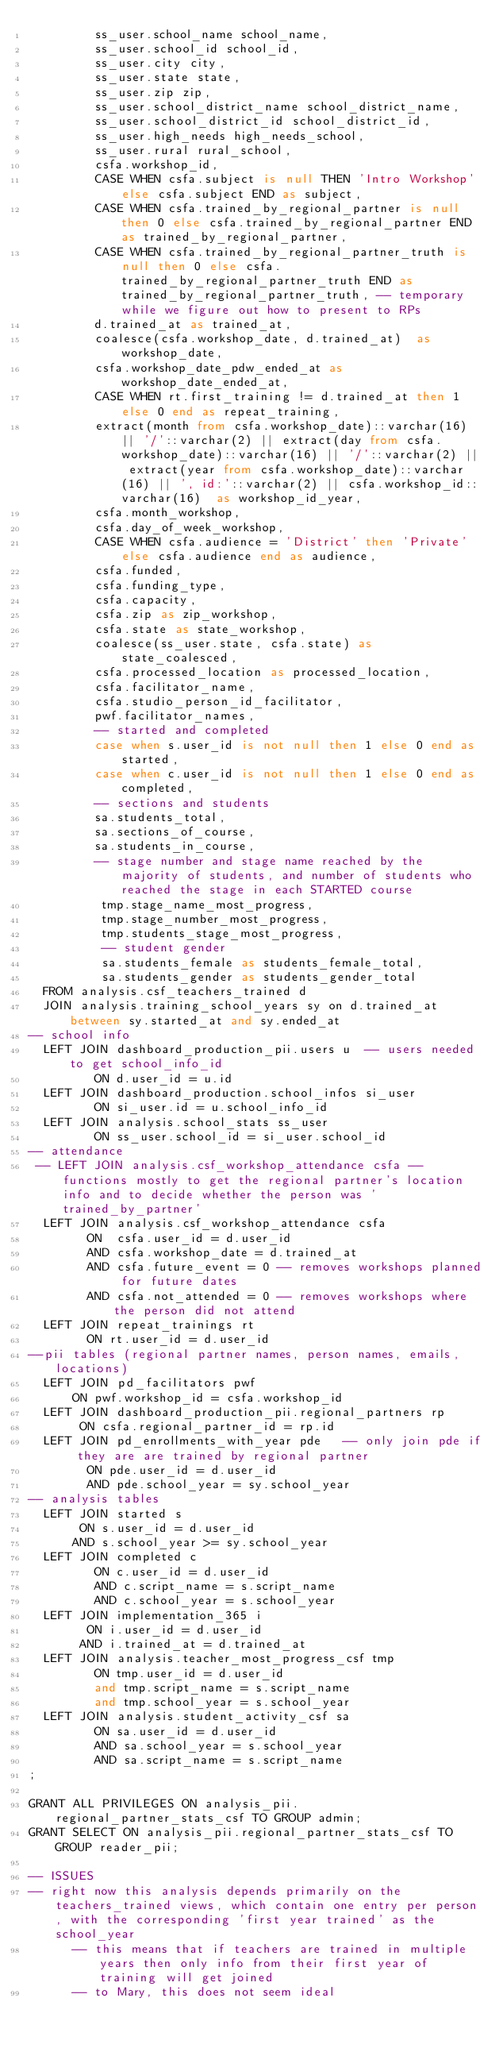Convert code to text. <code><loc_0><loc_0><loc_500><loc_500><_SQL_>         ss_user.school_name school_name,
         ss_user.school_id school_id,
         ss_user.city city,
         ss_user.state state,
         ss_user.zip zip,
         ss_user.school_district_name school_district_name,
         ss_user.school_district_id school_district_id,
         ss_user.high_needs high_needs_school,
         ss_user.rural rural_school, 
         csfa.workshop_id,
         CASE WHEN csfa.subject is null THEN 'Intro Workshop' else csfa.subject END as subject,
         CASE WHEN csfa.trained_by_regional_partner is null then 0 else csfa.trained_by_regional_partner END as trained_by_regional_partner,
         CASE WHEN csfa.trained_by_regional_partner_truth is null then 0 else csfa.trained_by_regional_partner_truth END as trained_by_regional_partner_truth, -- temporary while we figure out how to present to RPs
         d.trained_at as trained_at,
         coalesce(csfa.workshop_date, d.trained_at)  as workshop_date, 
         csfa.workshop_date_pdw_ended_at as workshop_date_ended_at,
         CASE WHEN rt.first_training != d.trained_at then 1 else 0 end as repeat_training,
         extract(month from csfa.workshop_date)::varchar(16) || '/'::varchar(2) || extract(day from csfa.workshop_date)::varchar(16) || '/'::varchar(2) || extract(year from csfa.workshop_date)::varchar(16) || ', id:'::varchar(2) || csfa.workshop_id::varchar(16)  as workshop_id_year,
         csfa.month_workshop,
         csfa.day_of_week_workshop,
         CASE WHEN csfa.audience = 'District' then 'Private' else csfa.audience end as audience,
         csfa.funded,
         csfa.funding_type,
         csfa.capacity,
         csfa.zip as zip_workshop,
         csfa.state as state_workshop,
         coalesce(ss_user.state, csfa.state) as state_coalesced,
         csfa.processed_location as processed_location,
         csfa.facilitator_name, 
         csfa.studio_person_id_facilitator,     
         pwf.facilitator_names,
         -- started and completed
         case when s.user_id is not null then 1 else 0 end as started,
         case when c.user_id is not null then 1 else 0 end as completed,
         -- sections and students   
         sa.students_total,         
         sa.sections_of_course,
         sa.students_in_course,
         -- stage number and stage name reached by the majority of students, and number of students who reached the stage in each STARTED course
          tmp.stage_name_most_progress,
          tmp.stage_number_most_progress, 
          tmp.students_stage_most_progress,
          -- student gender
          sa.students_female as students_female_total,
          sa.students_gender as students_gender_total
  FROM analysis.csf_teachers_trained d 
  JOIN analysis.training_school_years sy on d.trained_at between sy.started_at and sy.ended_at
-- school info
  LEFT JOIN dashboard_production_pii.users u  -- users needed to get school_info_id
         ON d.user_id = u.id
  LEFT JOIN dashboard_production.school_infos si_user
         ON si_user.id = u.school_info_id
  LEFT JOIN analysis.school_stats ss_user
         ON ss_user.school_id = si_user.school_id
-- attendance
 -- LEFT JOIN analysis.csf_workshop_attendance csfa -- functions mostly to get the regional partner's location info and to decide whether the person was 'trained_by_partner'
  LEFT JOIN analysis.csf_workshop_attendance csfa   
        ON  csfa.user_id = d.user_id
        AND csfa.workshop_date = d.trained_at 
        AND csfa.future_event = 0 -- removes workshops planned for future dates
        AND csfa.not_attended = 0 -- removes workshops where the person did not attend
  LEFT JOIN repeat_trainings rt
        ON rt.user_id = d.user_id
--pii tables (regional partner names, person names, emails, locations)
  LEFT JOIN pd_facilitators pwf
      ON pwf.workshop_id = csfa.workshop_id
  LEFT JOIN dashboard_production_pii.regional_partners rp  
       ON csfa.regional_partner_id = rp.id 
  LEFT JOIN pd_enrollments_with_year pde   -- only join pde if they are are trained by regional partner 
        ON pde.user_id = d.user_id
        AND pde.school_year = sy.school_year 
-- analysis tables 
  LEFT JOIN started s
       ON s.user_id = d.user_id
      AND s.school_year >= sy.school_year 
  LEFT JOIN completed c
         ON c.user_id = d.user_id
         AND c.script_name = s.script_name
         AND c.school_year = s.school_year
  LEFT JOIN implementation_365 i
        ON i.user_id = d.user_id
       AND i.trained_at = d.trained_at
  LEFT JOIN analysis.teacher_most_progress_csf tmp
         ON tmp.user_id = d.user_id
         and tmp.script_name = s.script_name
         and tmp.school_year = s.school_year
  LEFT JOIN analysis.student_activity_csf sa 
         ON sa.user_id = d.user_id
         AND sa.school_year = s.school_year
         AND sa.script_name = s.script_name
;

GRANT ALL PRIVILEGES ON analysis_pii.regional_partner_stats_csf TO GROUP admin;
GRANT SELECT ON analysis_pii.regional_partner_stats_csf TO GROUP reader_pii;

-- ISSUES
-- right now this analysis depends primarily on the teachers_trained views, which contain one entry per person, with the corresponding 'first year trained' as the school_year
      -- this means that if teachers are trained in multiple years then only info from their first year of training will get joined
      -- to Mary, this does not seem ideal 
</code> 